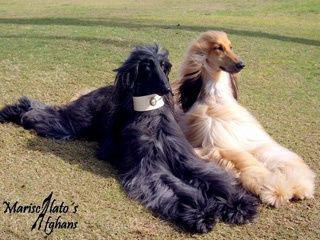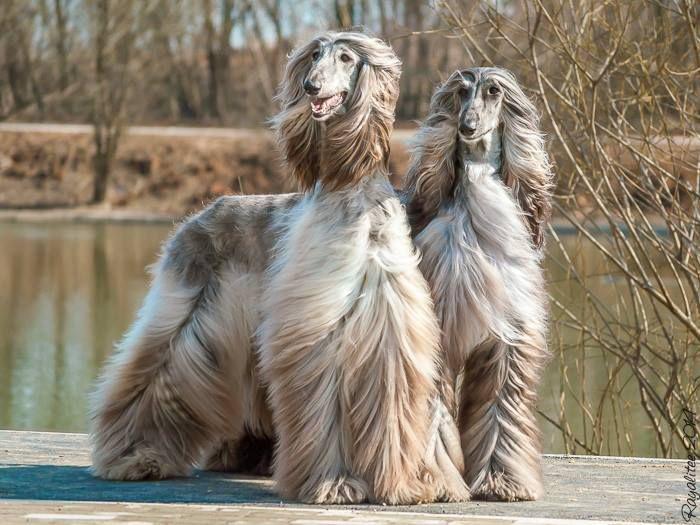The first image is the image on the left, the second image is the image on the right. For the images displayed, is the sentence "The left and right image contains the same number of dogs." factually correct? Answer yes or no. Yes. The first image is the image on the left, the second image is the image on the right. Given the left and right images, does the statement "There are four dogs in total." hold true? Answer yes or no. Yes. 